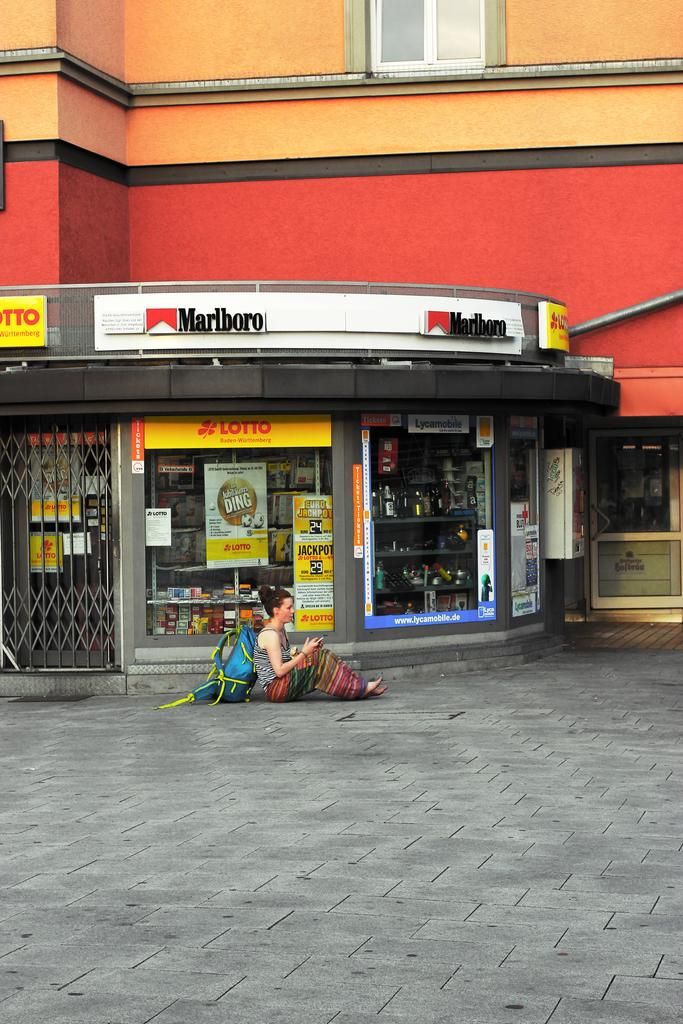<image>
Offer a succinct explanation of the picture presented. Woman sitting in front of a store with a sign that says Marlboro. 